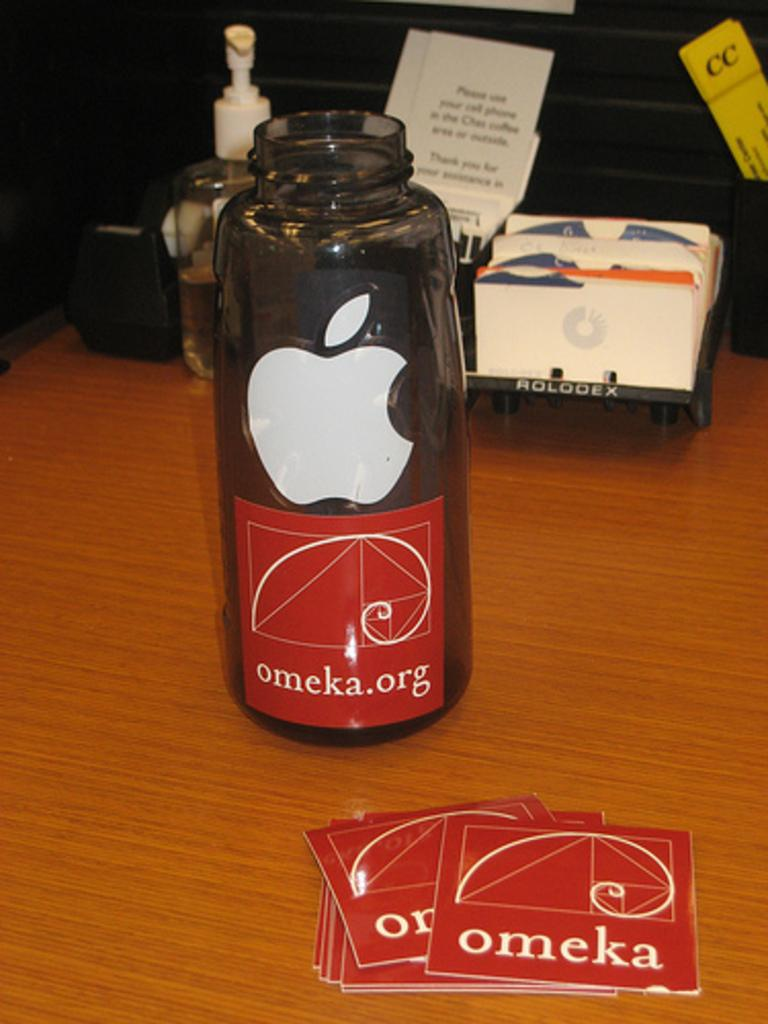Provide a one-sentence caption for the provided image. a red omeka.org label sticker is seen on an apple water bottle. 